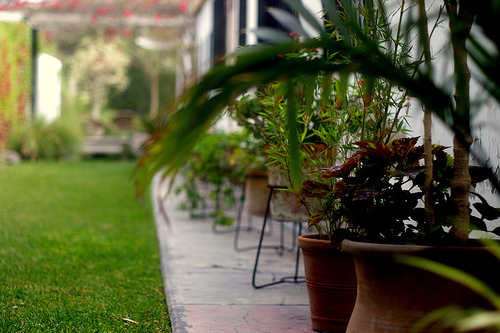<image>
Is there a plant in the planter? Yes. The plant is contained within or inside the planter, showing a containment relationship. 